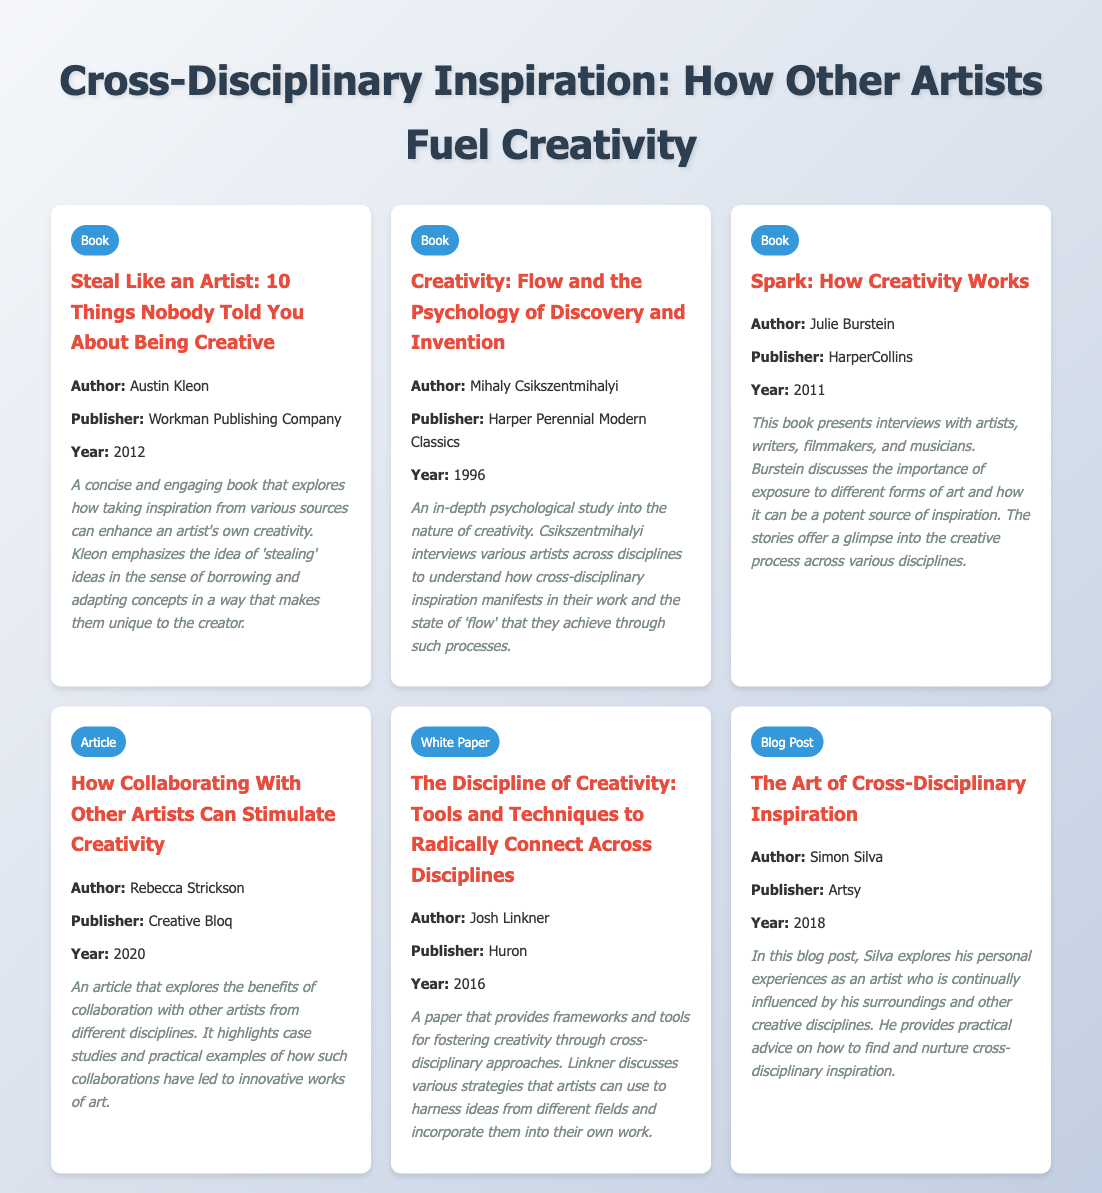What is the title of the first book listed? The title is provided in the first entry of the bibliography, which is "Steal Like an Artist: 10 Things Nobody Told You About Being Creative."
Answer: Steal Like an Artist: 10 Things Nobody Told You About Being Creative Who is the author of the article "How Collaborating With Other Artists Can Stimulate Creativity"? The author's name is stated under the article entry in the bibliography as Rebecca Strickson.
Answer: Rebecca Strickson What year was "Creativity: Flow and the Psychology of Discovery and Invention" published? The publication year is mentioned in the book entry, which shows it was published in 1996.
Answer: 1996 What type of document is "The Discipline of Creativity: Tools and Techniques to Radically Connect Across Disciplines"? The type is specified in the entry, indicating it is a white paper.
Answer: White Paper Which publisher released the book "Spark: How Creativity Works"? The publisher's name is included in the entry details, which is HarperCollins for this book.
Answer: HarperCollins What is the main focus of Julie Burstein's book according to the details? The details describe that the focus is on interviews with various artists and the role of different art forms in inspiring creativity.
Answer: Exposure to different forms of art What does Austin Kleon emphasize in his book regarding inspiration? The details in the entry specify that Kleon emphasizes the idea of 'stealing' ideas in a unique way for creators.
Answer: 'Stealing' ideas In which document type is Simon Silva's work categorized? The document type for Silva's entry is listed as a blog post.
Answer: Blog Post 